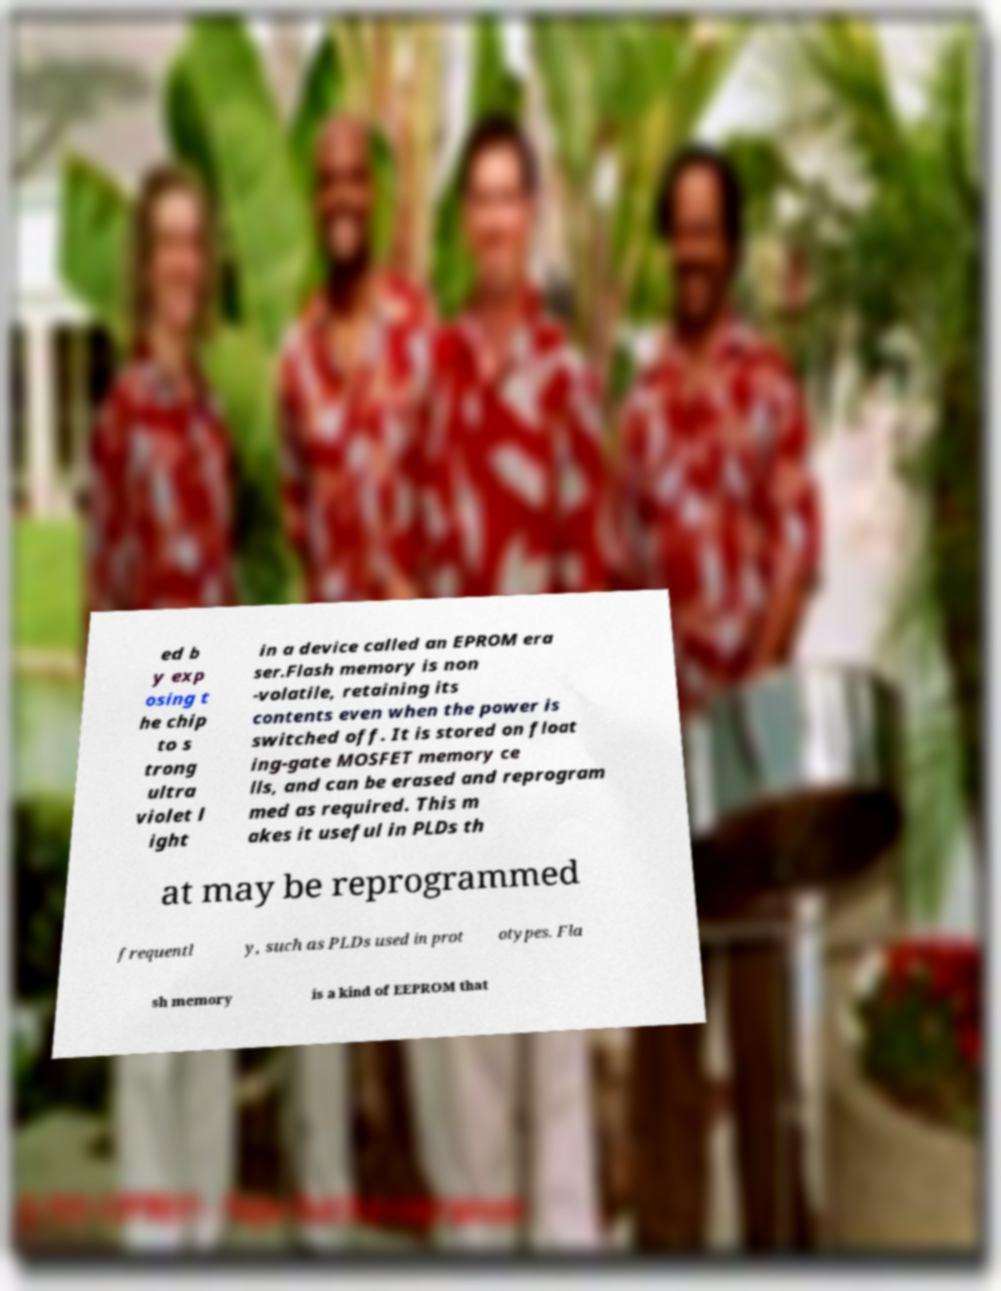I need the written content from this picture converted into text. Can you do that? ed b y exp osing t he chip to s trong ultra violet l ight in a device called an EPROM era ser.Flash memory is non -volatile, retaining its contents even when the power is switched off. It is stored on float ing-gate MOSFET memory ce lls, and can be erased and reprogram med as required. This m akes it useful in PLDs th at may be reprogrammed frequentl y, such as PLDs used in prot otypes. Fla sh memory is a kind of EEPROM that 